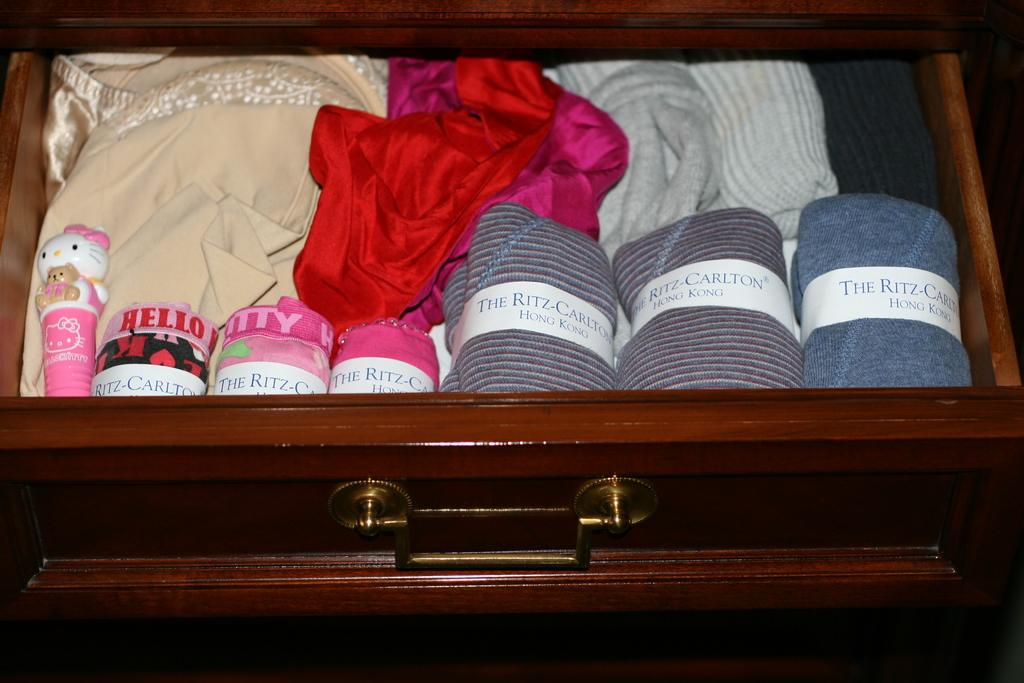<image>
Share a concise interpretation of the image provided. Several pieces of clothing are shown in a drawer wrapped with a paper that says The Ritz Carlton Hong Kong. 